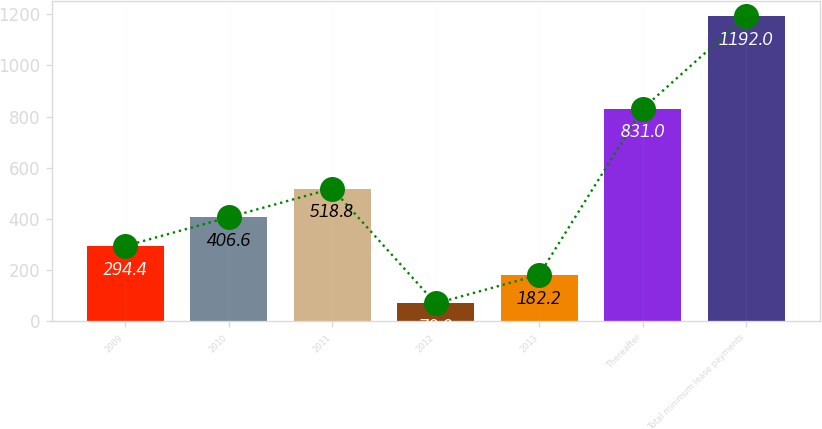Convert chart. <chart><loc_0><loc_0><loc_500><loc_500><bar_chart><fcel>2009<fcel>2010<fcel>2011<fcel>2012<fcel>2013<fcel>Thereafter<fcel>Total minimum lease payments<nl><fcel>294.4<fcel>406.6<fcel>518.8<fcel>70<fcel>182.2<fcel>831<fcel>1192<nl></chart> 